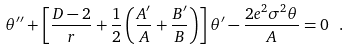Convert formula to latex. <formula><loc_0><loc_0><loc_500><loc_500>\theta ^ { \prime \prime } + \left [ \frac { D - 2 } { r } + \frac { 1 } { 2 } \left ( \frac { A ^ { \prime } } { A } + \frac { B ^ { \prime } } { B } \right ) \right ] \theta ^ { \prime } - \frac { 2 e ^ { 2 } \sigma ^ { 2 } \theta } { A } = 0 \ .</formula> 